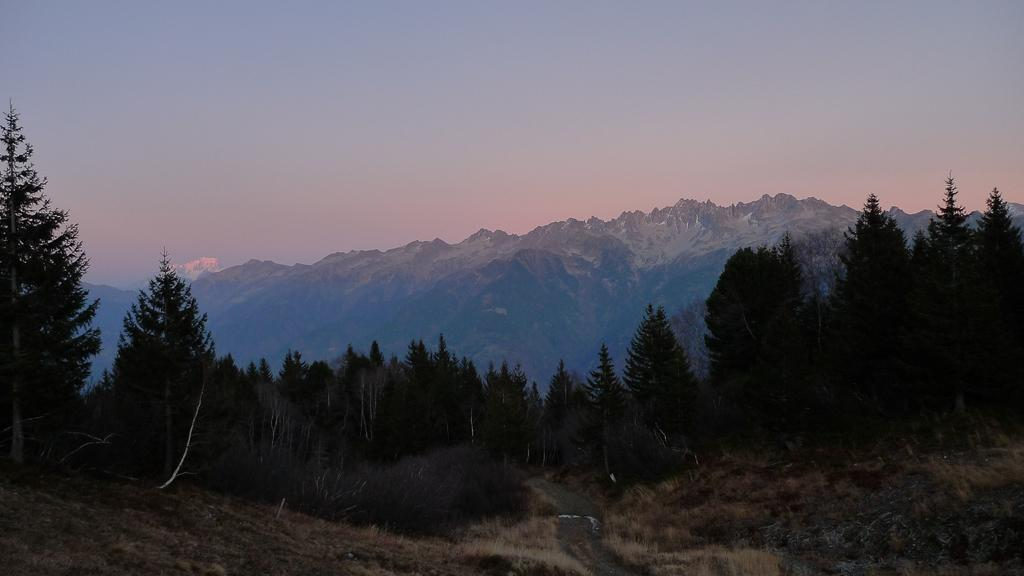What type of vegetation can be seen in the image? There is grass in the image. What other natural elements are present in the image? There are many trees in the image. What can be seen in the distance in the image? There are mountains visible in the background of the image. What is visible above the trees and mountains in the image? The sky is visible in the background of the image. Where is the nearest airport to the location depicted in the image? The image does not provide any information about the location or the nearest airport. 